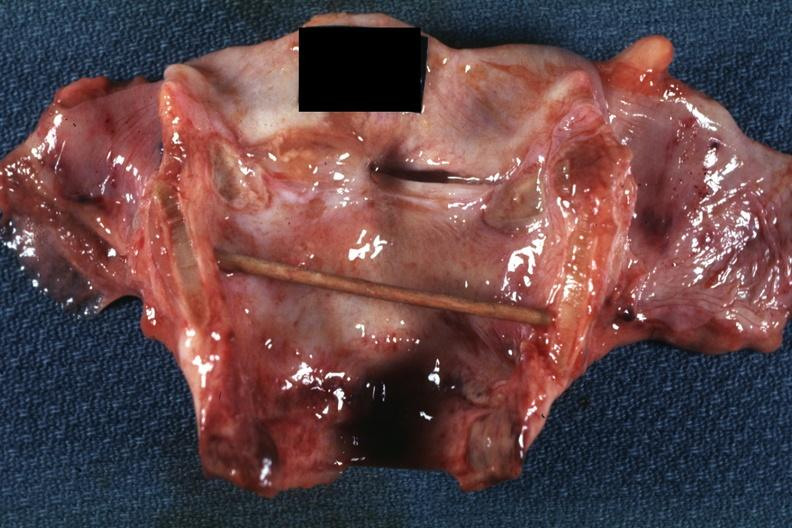s larynx present?
Answer the question using a single word or phrase. Yes 